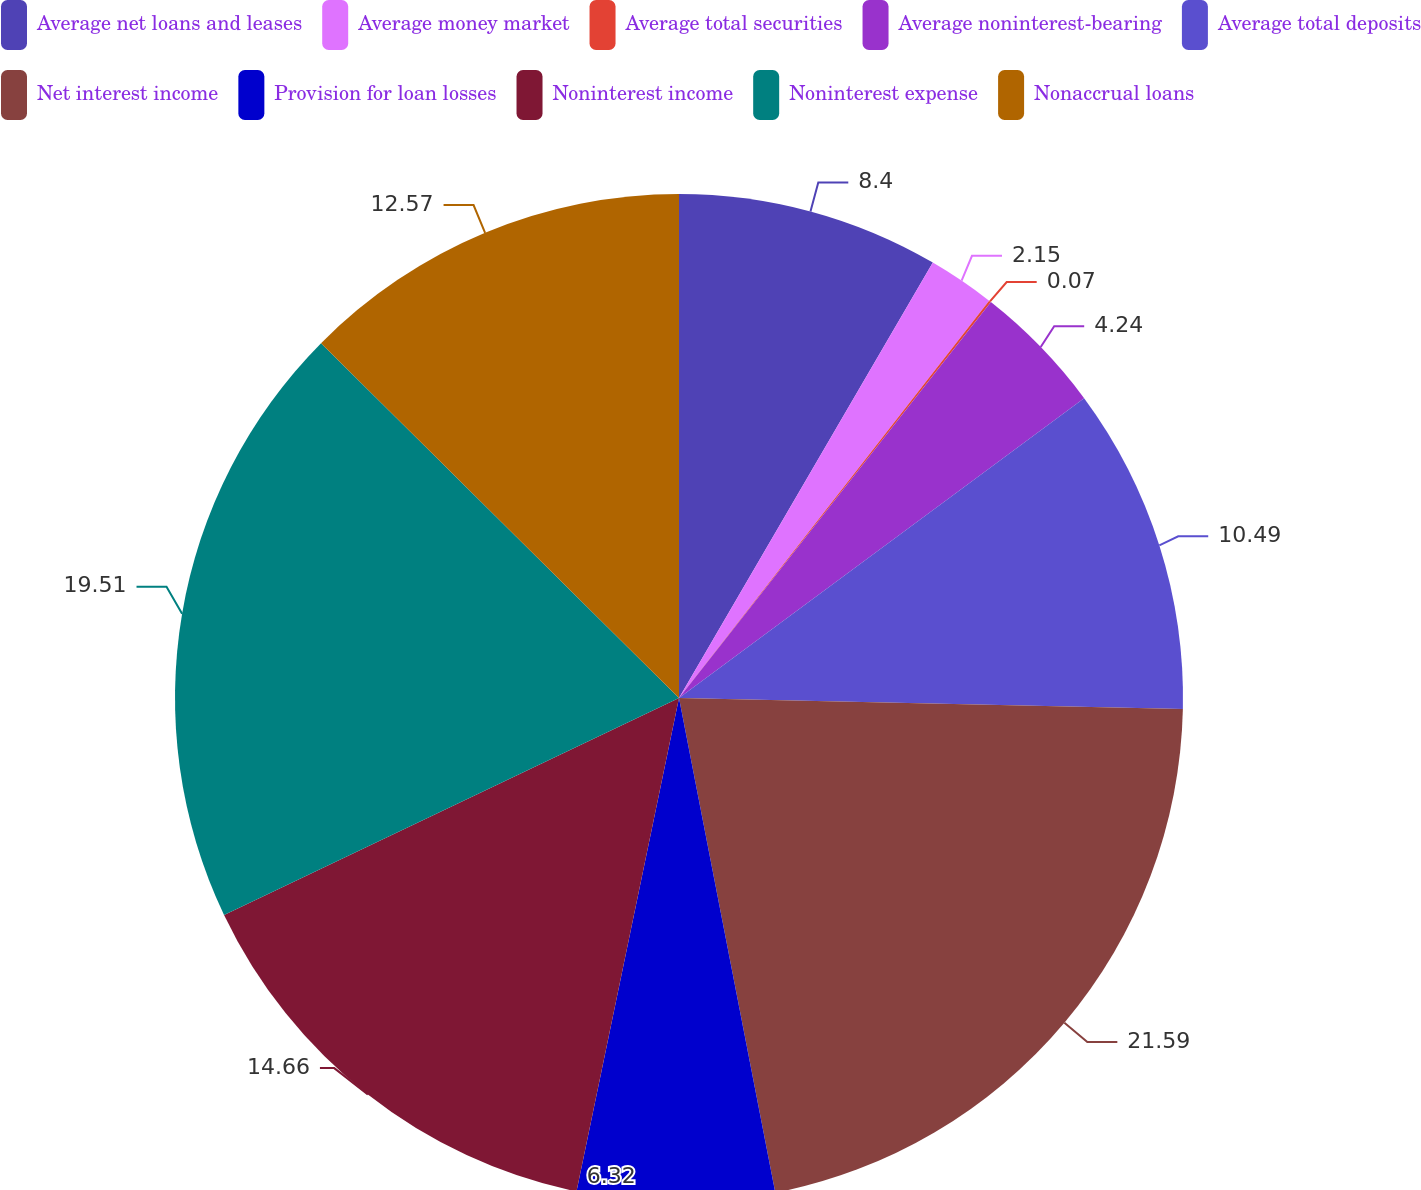<chart> <loc_0><loc_0><loc_500><loc_500><pie_chart><fcel>Average net loans and leases<fcel>Average money market<fcel>Average total securities<fcel>Average noninterest-bearing<fcel>Average total deposits<fcel>Net interest income<fcel>Provision for loan losses<fcel>Noninterest income<fcel>Noninterest expense<fcel>Nonaccrual loans<nl><fcel>8.4%<fcel>2.15%<fcel>0.07%<fcel>4.24%<fcel>10.49%<fcel>21.59%<fcel>6.32%<fcel>14.66%<fcel>19.51%<fcel>12.57%<nl></chart> 